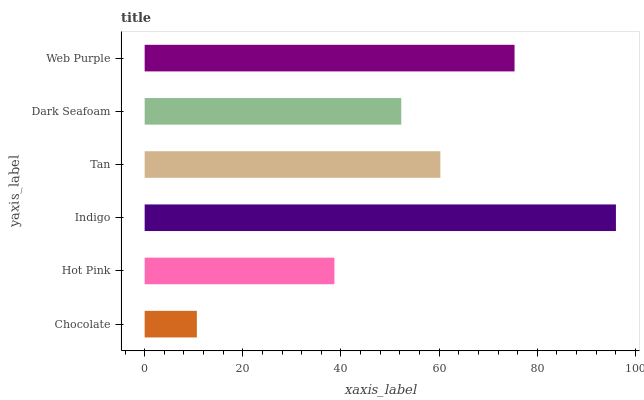Is Chocolate the minimum?
Answer yes or no. Yes. Is Indigo the maximum?
Answer yes or no. Yes. Is Hot Pink the minimum?
Answer yes or no. No. Is Hot Pink the maximum?
Answer yes or no. No. Is Hot Pink greater than Chocolate?
Answer yes or no. Yes. Is Chocolate less than Hot Pink?
Answer yes or no. Yes. Is Chocolate greater than Hot Pink?
Answer yes or no. No. Is Hot Pink less than Chocolate?
Answer yes or no. No. Is Tan the high median?
Answer yes or no. Yes. Is Dark Seafoam the low median?
Answer yes or no. Yes. Is Web Purple the high median?
Answer yes or no. No. Is Tan the low median?
Answer yes or no. No. 